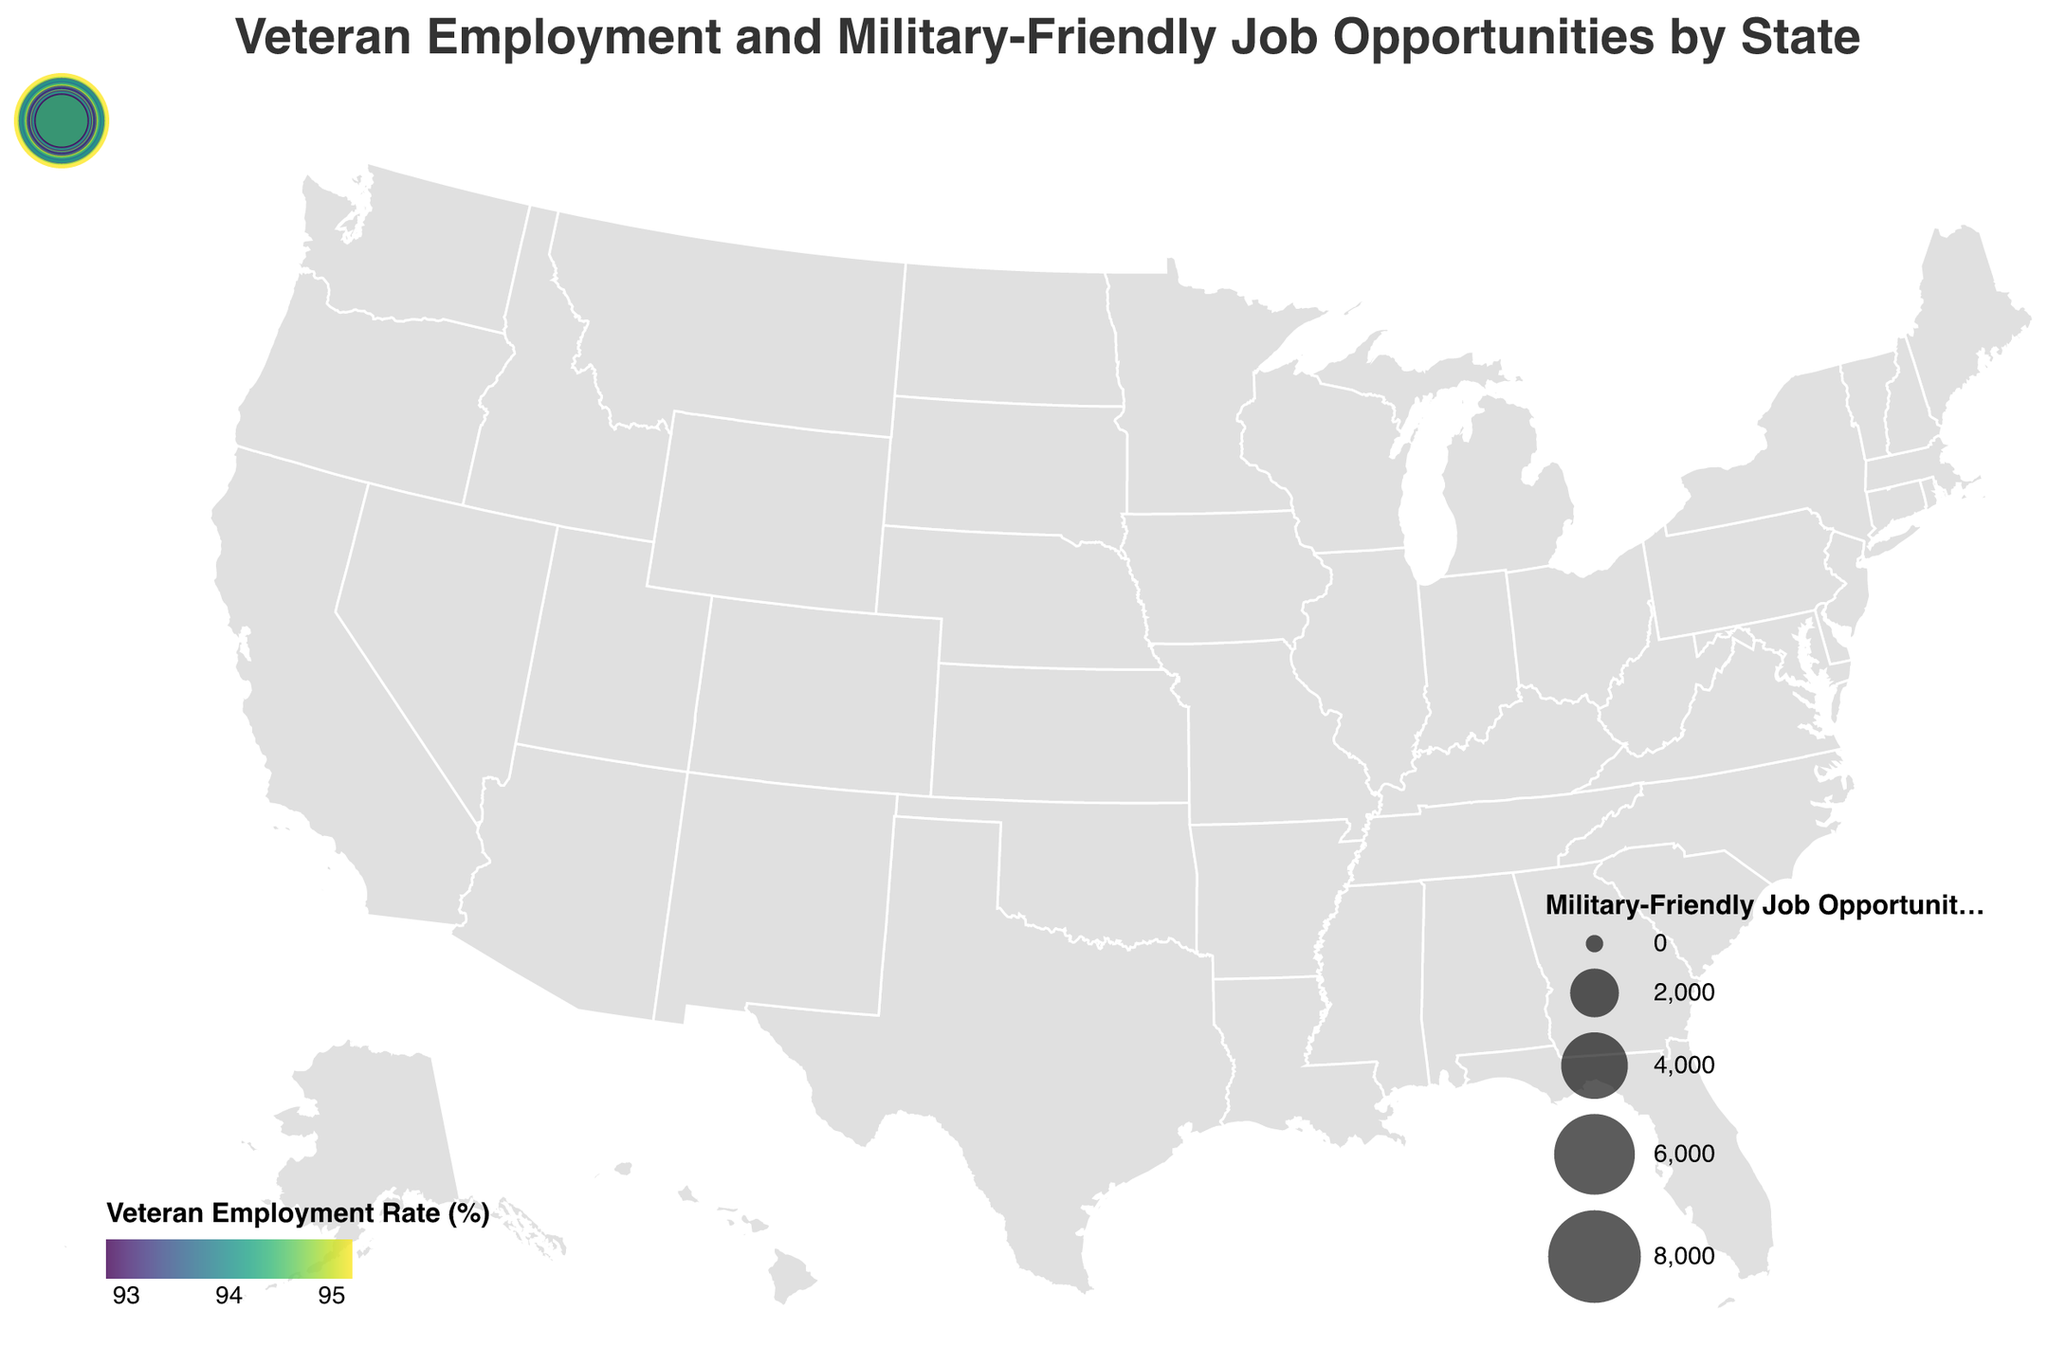What state has the highest veteran employment rate? The state with the highest veteran employment rate is Texas, with an employment rate of 95.2%. By looking at the legend, the color corresponding to Texas will be the darkest among the states representing higher employment rates.
Answer: Texas Which state has the greatest number of military-friendly job opportunities? The state with the largest circle, indicating the highest number of military-friendly job opportunities, is Texas with 8500 job opportunities.
Answer: Texas Which state has the lowest veteran employment rate? By identifying the lightest color on the map, it shows that Kentucky has the lowest veteran employment rate at 92.8%.
Answer: Kentucky What is the relationship between veteran employment rate and military-friendly job opportunities in Texas? Texas has both the highest veteran employment rate at 95.2% and the highest number of military-friendly job opportunities at 8500. This suggests a positive correlation between employment rate and job opportunities in Texas.
Answer: Positive correlation What’s the total number of military-friendly job opportunities in Virginia and California combined? Virginia has 7200 job opportunities and California has 6800. Adding them together gives 7200 + 6800 = 14000.
Answer: 14000 Which state has a higher veteran employment rate, Washington or Arizona? Washington has a veteran employment rate of 94.5%, whereas Arizona has a rate of 93.3%. Therefore, Washington has a higher veteran employment rate.
Answer: Washington What is the average veteran employment rate of the top 3 states with the most military-friendly job opportunities? The top 3 states with the most military-friendly job opportunities are Texas, Virginia, and California. Their employment rates are 95.2%, 94.8%, and 93.5% respectively. The average is (95.2 + 94.8 + 93.5) / 3 ≈ 94.5%.
Answer: 94.5% Which states have veteran employment rates greater than 94% but fewer than 5000 military-friendly job opportunities? By examining the states with employment rates above 94% and counting job opportunities below 5000, the states are Washington (5300 jobs, which is more than 5000) and Colorado (4800 jobs). Thus, only Colorado meets both conditions.
Answer: Colorado 